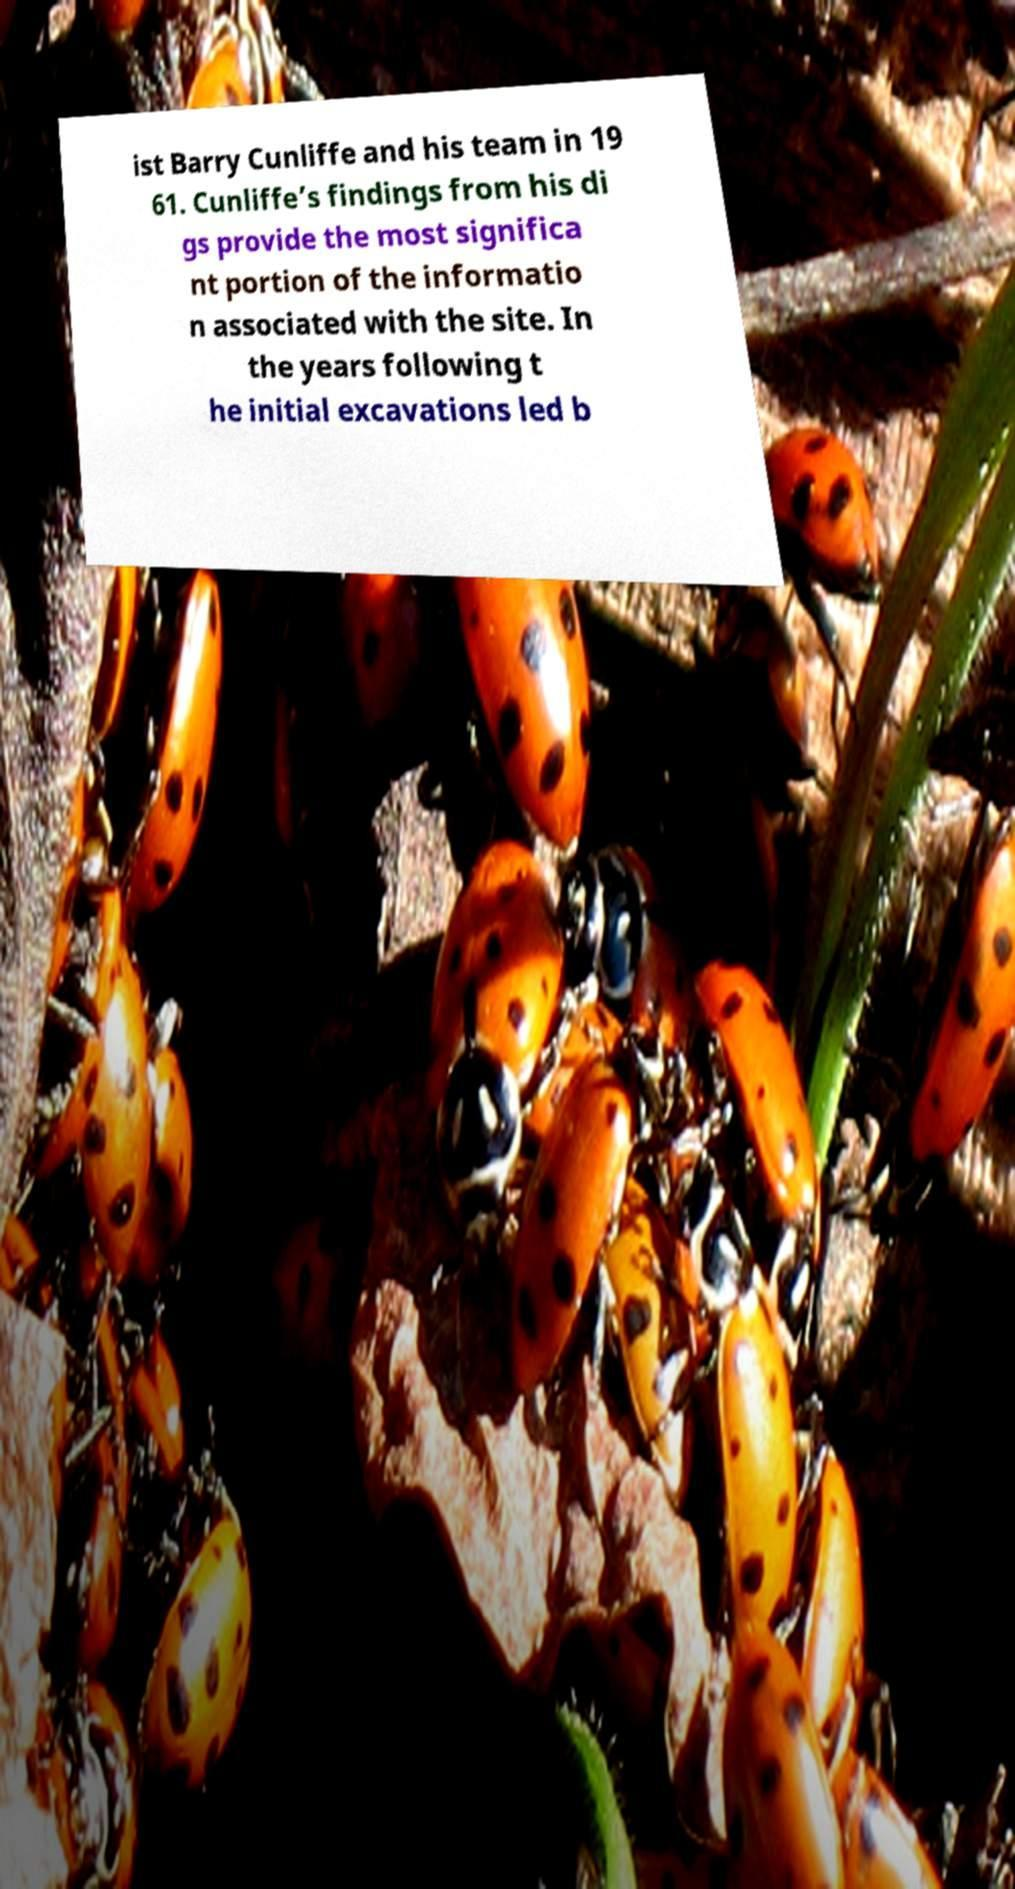For documentation purposes, I need the text within this image transcribed. Could you provide that? ist Barry Cunliffe and his team in 19 61. Cunliffe’s findings from his di gs provide the most significa nt portion of the informatio n associated with the site. In the years following t he initial excavations led b 